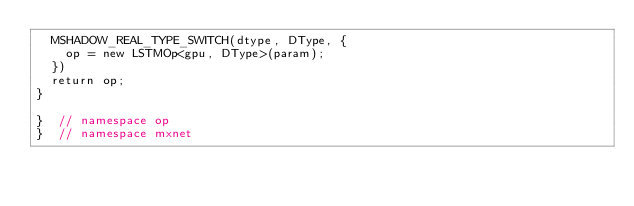Convert code to text. <code><loc_0><loc_0><loc_500><loc_500><_Cuda_>  MSHADOW_REAL_TYPE_SWITCH(dtype, DType, {
    op = new LSTMOp<gpu, DType>(param);
  })
  return op;
}

}  // namespace op
}  // namespace mxnet
</code> 